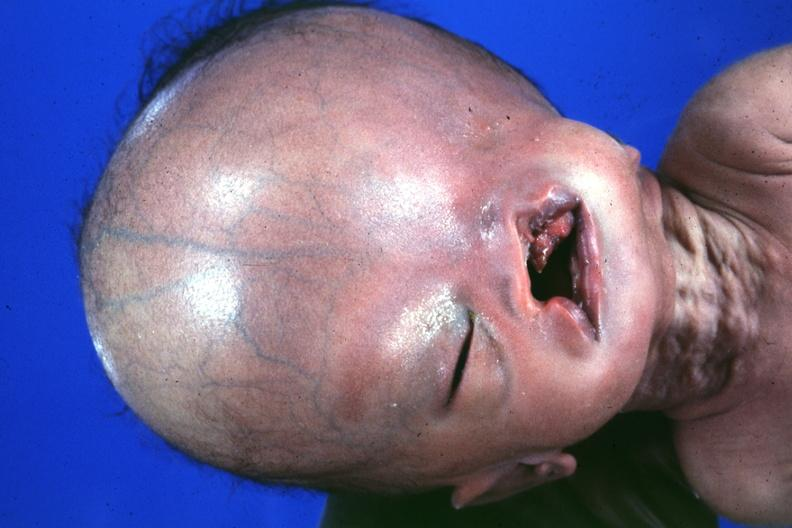what does absence of palpebral fissure cleft palate see?
Answer the question using a single word or phrase. Head see protocol for details 